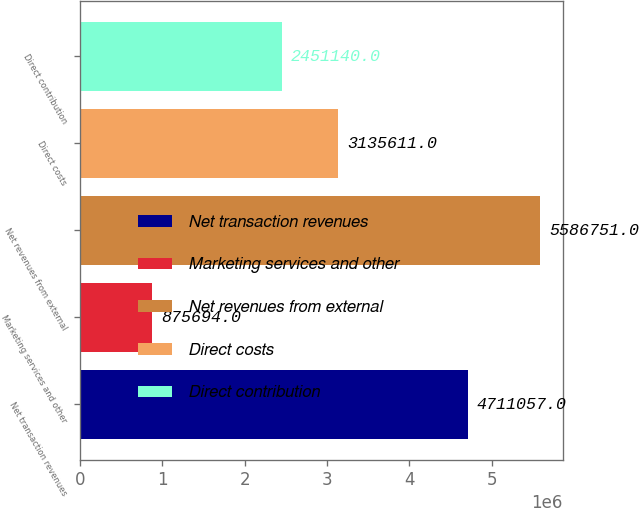<chart> <loc_0><loc_0><loc_500><loc_500><bar_chart><fcel>Net transaction revenues<fcel>Marketing services and other<fcel>Net revenues from external<fcel>Direct costs<fcel>Direct contribution<nl><fcel>4.71106e+06<fcel>875694<fcel>5.58675e+06<fcel>3.13561e+06<fcel>2.45114e+06<nl></chart> 